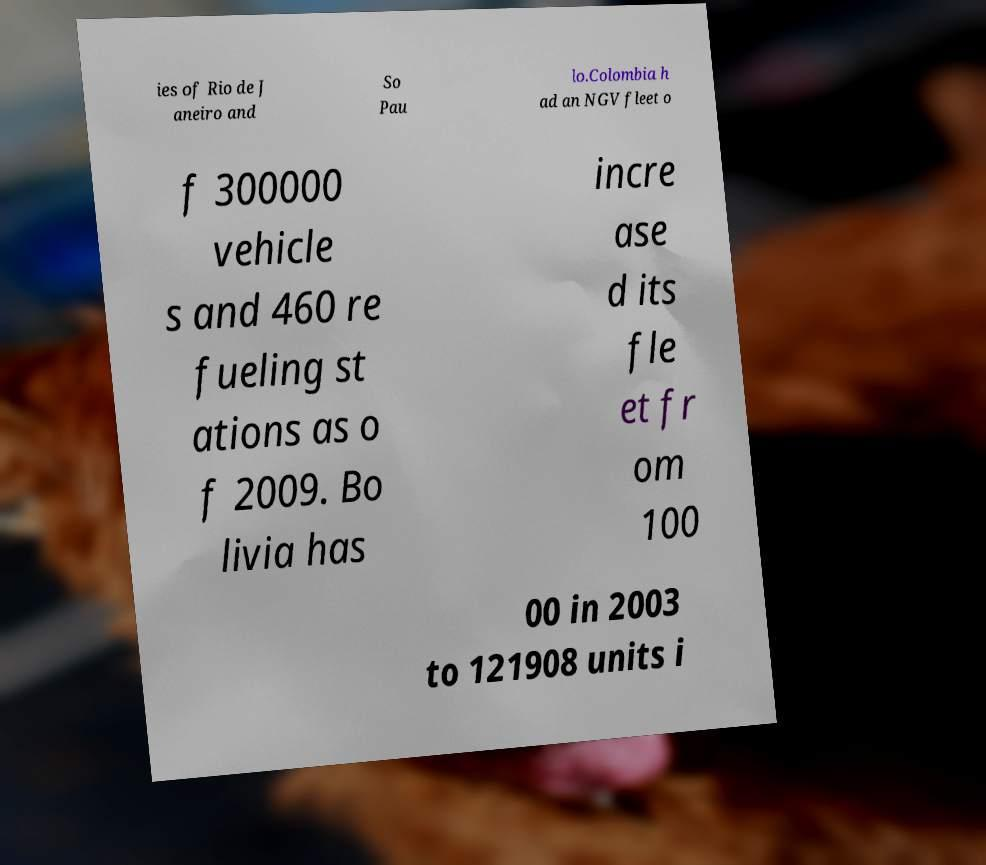There's text embedded in this image that I need extracted. Can you transcribe it verbatim? ies of Rio de J aneiro and So Pau lo.Colombia h ad an NGV fleet o f 300000 vehicle s and 460 re fueling st ations as o f 2009. Bo livia has incre ase d its fle et fr om 100 00 in 2003 to 121908 units i 